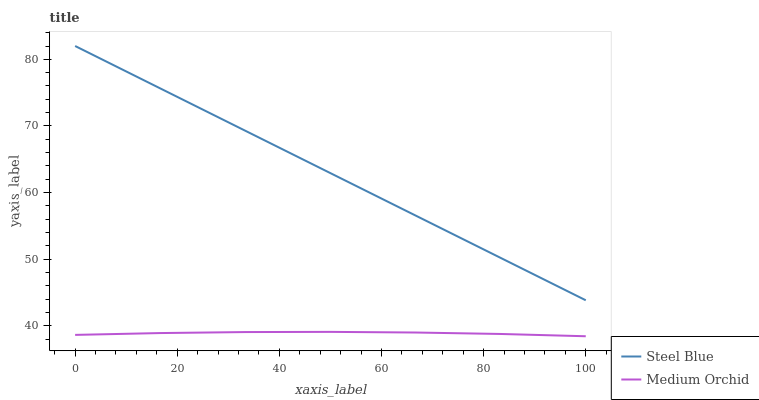Does Medium Orchid have the minimum area under the curve?
Answer yes or no. Yes. Does Steel Blue have the maximum area under the curve?
Answer yes or no. Yes. Does Steel Blue have the minimum area under the curve?
Answer yes or no. No. Is Steel Blue the smoothest?
Answer yes or no. Yes. Is Medium Orchid the roughest?
Answer yes or no. Yes. Is Steel Blue the roughest?
Answer yes or no. No. Does Steel Blue have the lowest value?
Answer yes or no. No. Does Steel Blue have the highest value?
Answer yes or no. Yes. Is Medium Orchid less than Steel Blue?
Answer yes or no. Yes. Is Steel Blue greater than Medium Orchid?
Answer yes or no. Yes. Does Medium Orchid intersect Steel Blue?
Answer yes or no. No. 